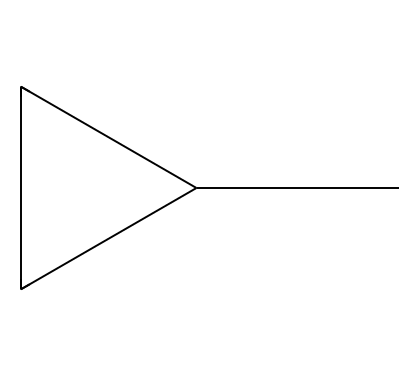What is the total number of carbon atoms in methylcyclopropane? The SMILES representation "CC1CC1" indicates that there are three carbon atoms present. The first 'C' is the methyl group, and the 'C1CC1' represents the three carbons in the cyclopropane ring.
Answer: three How many hydrogen atoms are attached to methylcyclopropane? The structure contains three carbon atoms; given that methylcyclopropane is a cycloalkane, the general formula is CnH2n. So for n = 3, the formula gives H6, meaning there are six hydrogen atoms attached.
Answer: six What is the degree of saturation in methylcyclopropane? The degree of saturation can be calculated based on the formula CnH2n, which for this compound results in calculating a degree of saturation of 1 due to it being a cycloalkane with a ring structure.
Answer: 1 Does methylcyclopropane contain any double bonds? Based on the given SMILES structure, there are no double bonds present as all carbon-to-carbon connections are single bonds. Therefore, it is fully saturated.
Answer: no What type of compound is methylcyclopropane classified as? Methylcyclopropane is classified under cycloalkanes because of its properties that involve a cyclic structure and only single carbon-carbon bonds, distinguishing it from other types of hydrocarbons.
Answer: cycloalkane How many rings are present in the structure of methylcyclopropane? The presence of the cyclopropane prefix indicates there is one ring in this structure, making it a cyclic compound.
Answer: one Is methylcyclopropane a potential biofuel additive for drone engines? Yes, based on its properties such as high energy content and good combustion characteristics, methylcyclopropane can potentially be used as a biofuel additive in drone engines.
Answer: yes 